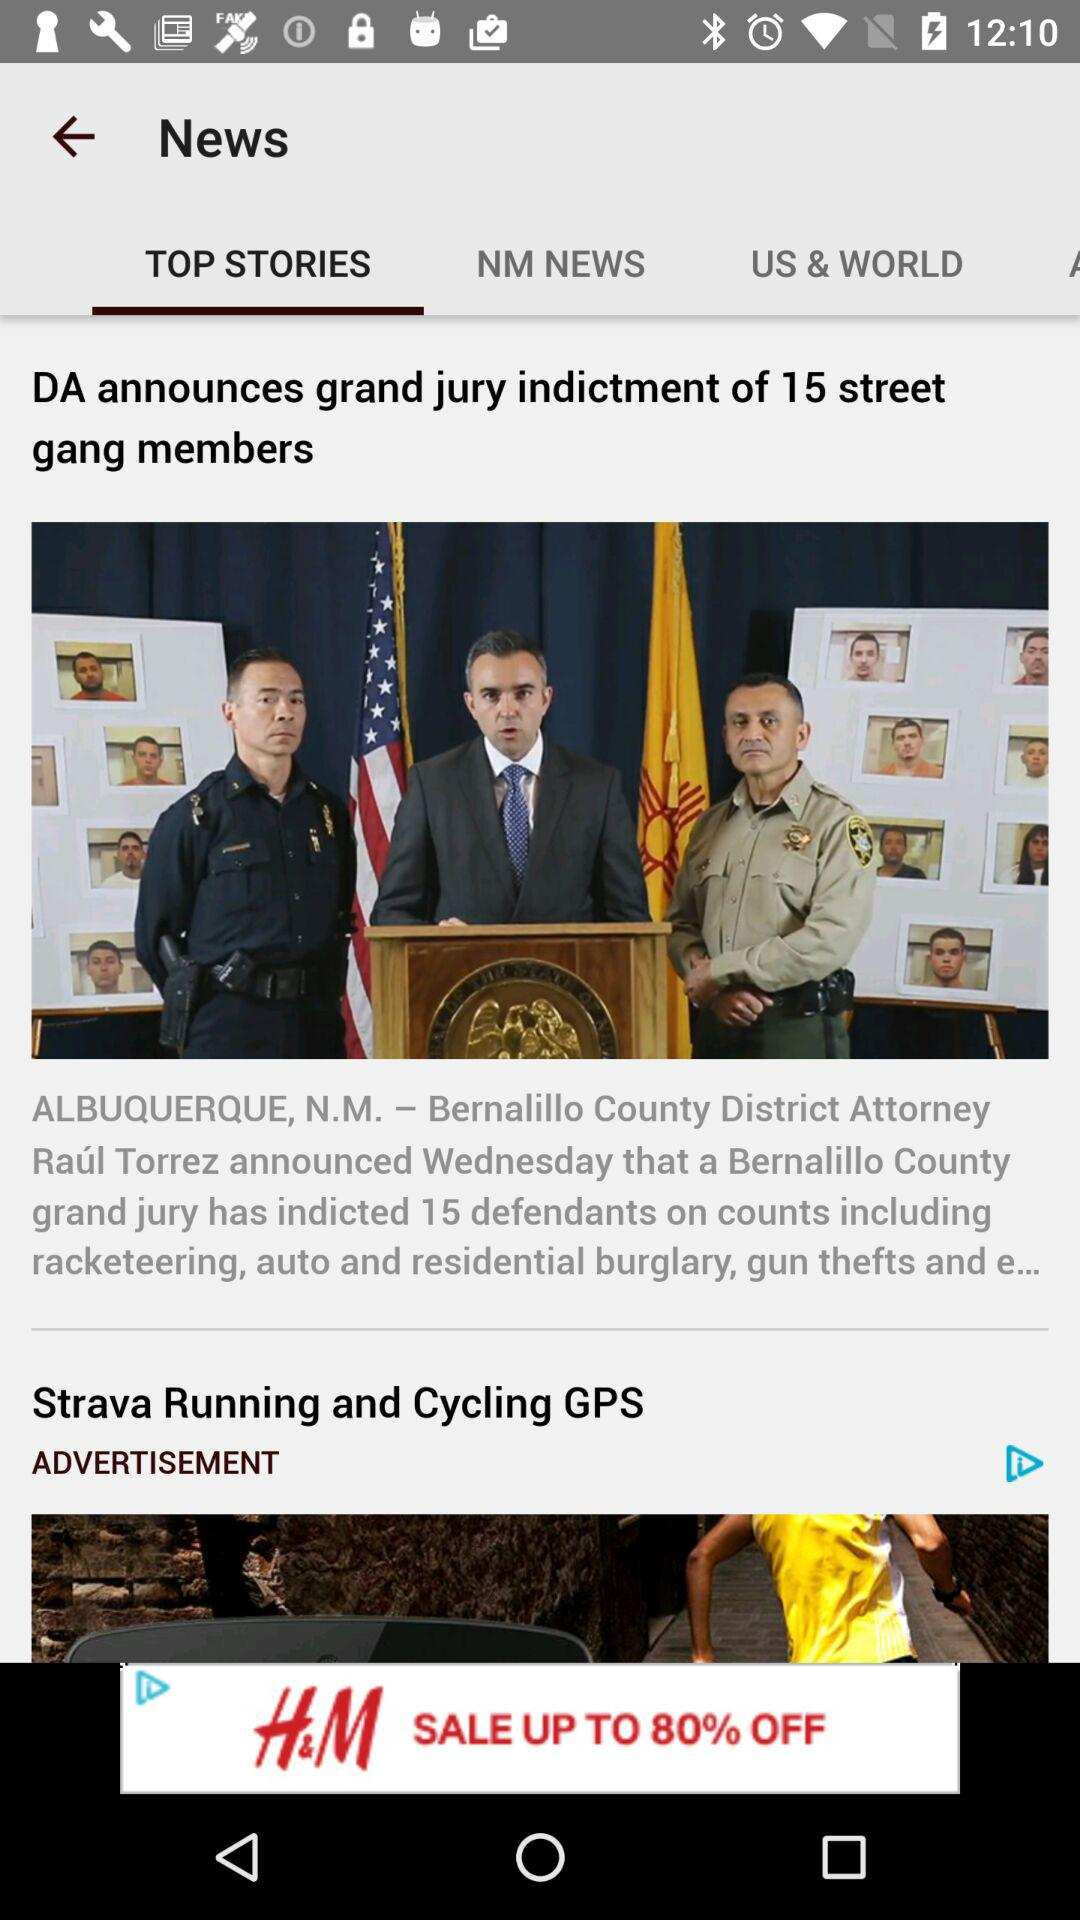What is the selected tab? The selected tab is "TOP STORIES". 